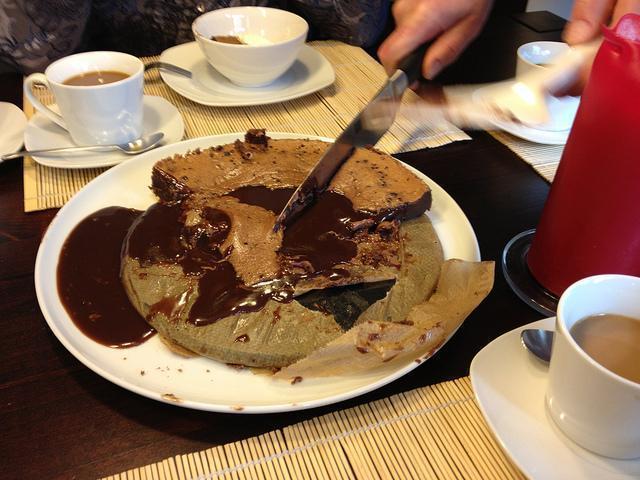What is being cut?
Select the accurate response from the four choices given to answer the question.
Options: Chocolate sauce, pudding, gooey cake, bread. Gooey cake. 